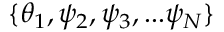Convert formula to latex. <formula><loc_0><loc_0><loc_500><loc_500>\{ \theta _ { 1 } , \psi _ { 2 } , \psi _ { 3 } , \dots \psi _ { N } \}</formula> 